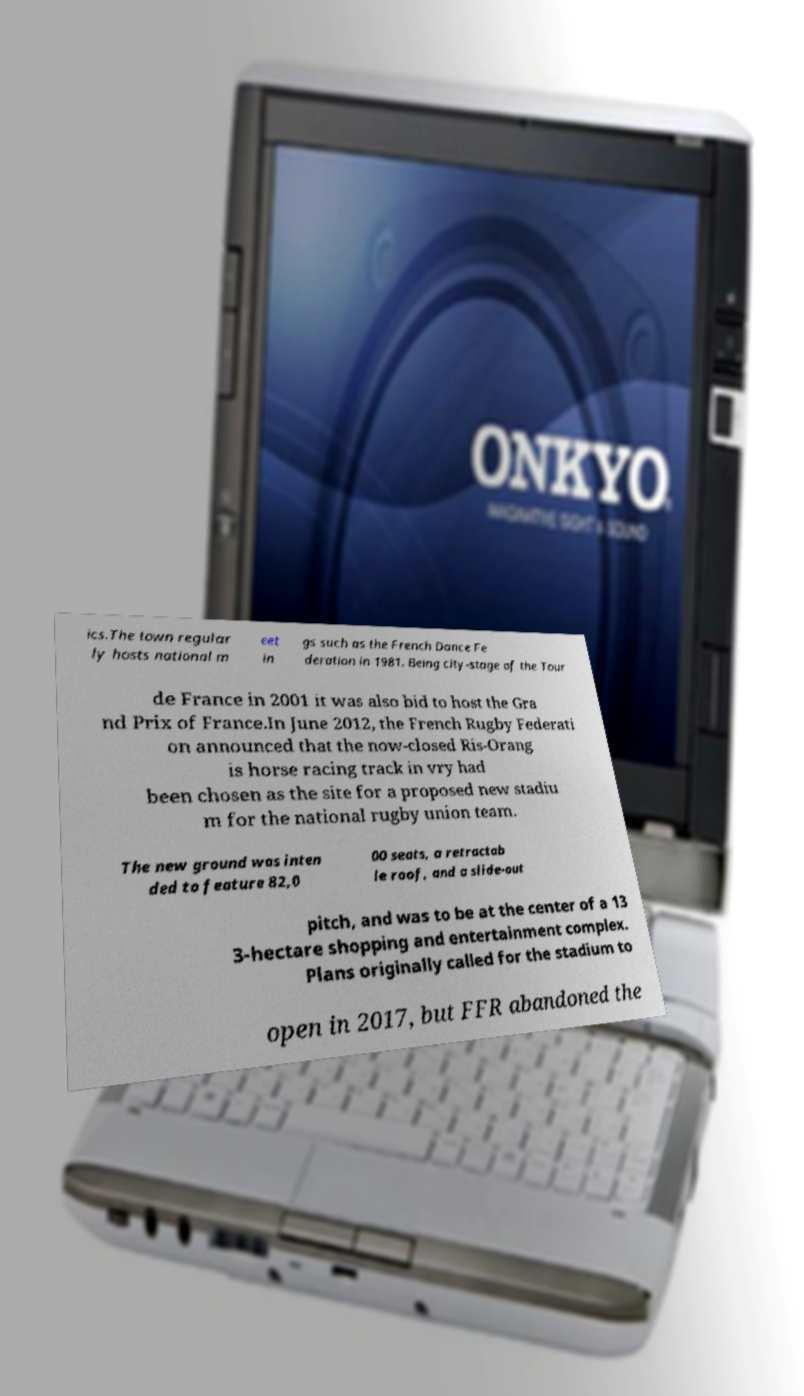Can you read and provide the text displayed in the image?This photo seems to have some interesting text. Can you extract and type it out for me? ics.The town regular ly hosts national m eet in gs such as the French Dance Fe deration in 1981. Being city-stage of the Tour de France in 2001 it was also bid to host the Gra nd Prix of France.In June 2012, the French Rugby Federati on announced that the now-closed Ris-Orang is horse racing track in vry had been chosen as the site for a proposed new stadiu m for the national rugby union team. The new ground was inten ded to feature 82,0 00 seats, a retractab le roof, and a slide-out pitch, and was to be at the center of a 13 3-hectare shopping and entertainment complex. Plans originally called for the stadium to open in 2017, but FFR abandoned the 